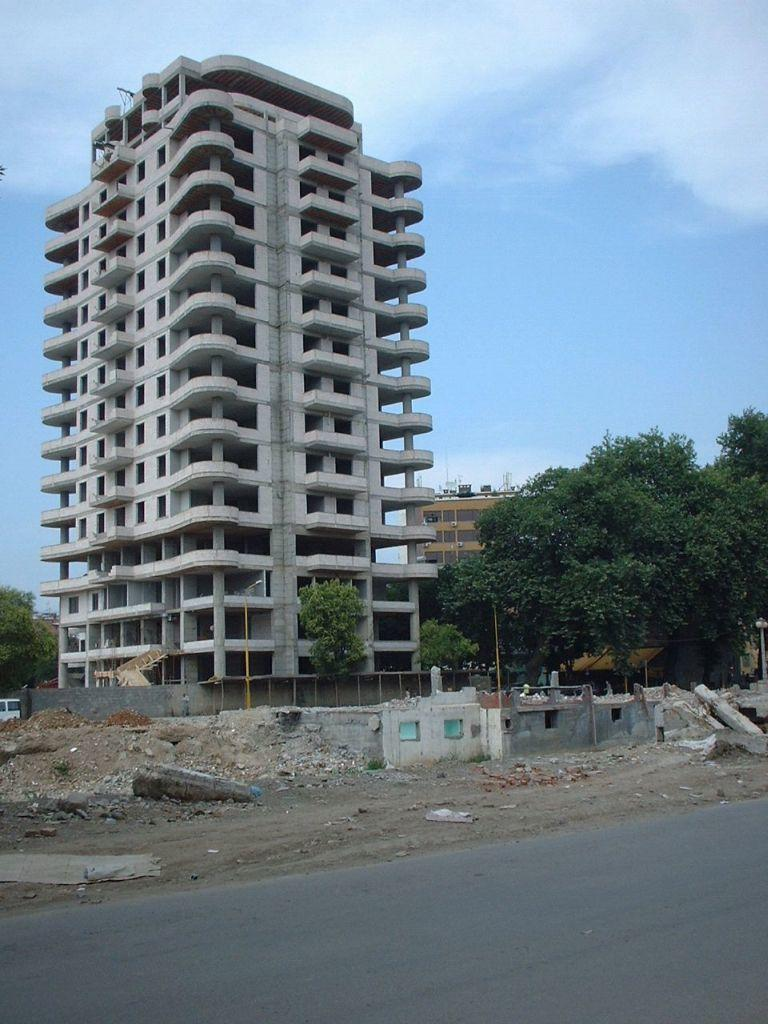What type of pathway is visible in the image? There is a road in the image. What type of natural elements can be seen in the image? There are trees in the image. What type of man-made structures are present in the image? There are buildings in the image. What other objects can be seen in the image? There are objects in the image. What can be seen in the background of the image? The sky is visible in the background of the image. What is the condition of the sky in the image? Clouds are present in the sky. What type of maid is visible in the image? There is no maid present in the image. What type of writer can be seen working on their latest novel in the image? There is no writer present in the image. 